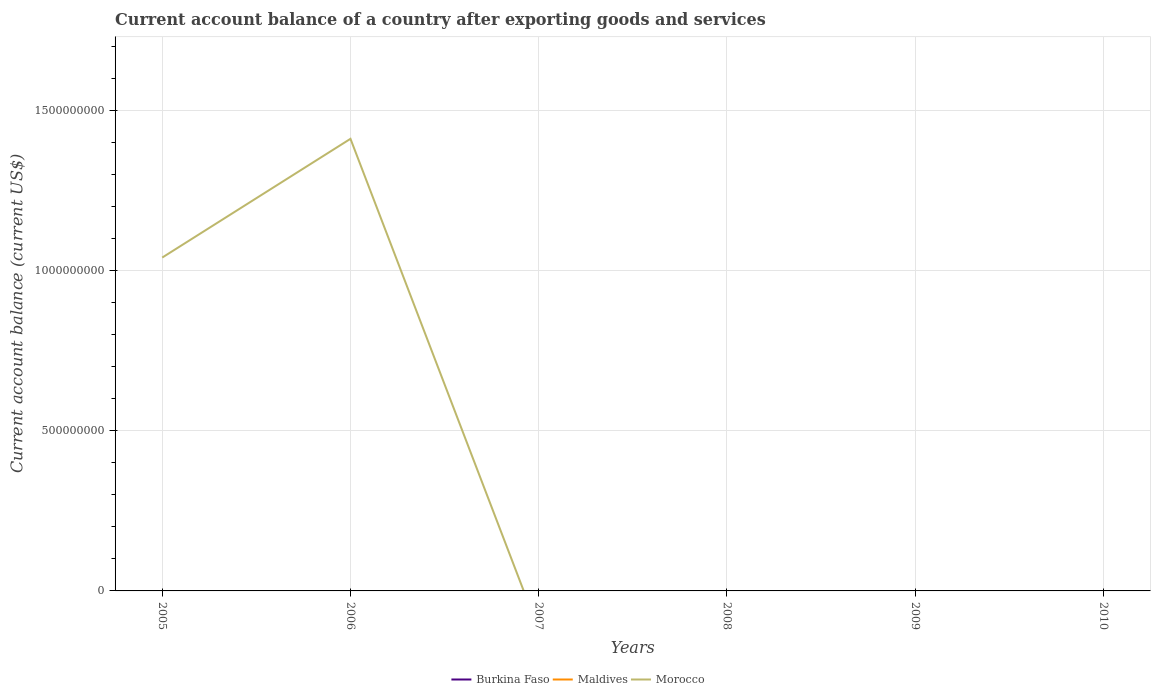How many different coloured lines are there?
Keep it short and to the point. 1. What is the difference between the highest and the second highest account balance in Morocco?
Ensure brevity in your answer.  1.41e+09. How many years are there in the graph?
Offer a very short reply. 6. Does the graph contain any zero values?
Your response must be concise. Yes. How many legend labels are there?
Your response must be concise. 3. How are the legend labels stacked?
Provide a short and direct response. Horizontal. What is the title of the graph?
Make the answer very short. Current account balance of a country after exporting goods and services. What is the label or title of the X-axis?
Provide a short and direct response. Years. What is the label or title of the Y-axis?
Your response must be concise. Current account balance (current US$). What is the Current account balance (current US$) in Maldives in 2005?
Provide a short and direct response. 0. What is the Current account balance (current US$) in Morocco in 2005?
Give a very brief answer. 1.04e+09. What is the Current account balance (current US$) of Burkina Faso in 2006?
Provide a succinct answer. 0. What is the Current account balance (current US$) of Maldives in 2006?
Provide a short and direct response. 0. What is the Current account balance (current US$) of Morocco in 2006?
Your answer should be compact. 1.41e+09. What is the Current account balance (current US$) in Morocco in 2007?
Offer a very short reply. 0. What is the Current account balance (current US$) of Burkina Faso in 2008?
Your answer should be compact. 0. What is the Current account balance (current US$) in Morocco in 2009?
Provide a short and direct response. 0. Across all years, what is the maximum Current account balance (current US$) of Morocco?
Your response must be concise. 1.41e+09. Across all years, what is the minimum Current account balance (current US$) in Morocco?
Your answer should be very brief. 0. What is the total Current account balance (current US$) of Morocco in the graph?
Make the answer very short. 2.45e+09. What is the difference between the Current account balance (current US$) of Morocco in 2005 and that in 2006?
Give a very brief answer. -3.71e+08. What is the average Current account balance (current US$) of Burkina Faso per year?
Your answer should be very brief. 0. What is the average Current account balance (current US$) of Maldives per year?
Make the answer very short. 0. What is the average Current account balance (current US$) of Morocco per year?
Offer a very short reply. 4.09e+08. What is the ratio of the Current account balance (current US$) in Morocco in 2005 to that in 2006?
Your answer should be very brief. 0.74. What is the difference between the highest and the lowest Current account balance (current US$) of Morocco?
Your answer should be very brief. 1.41e+09. 